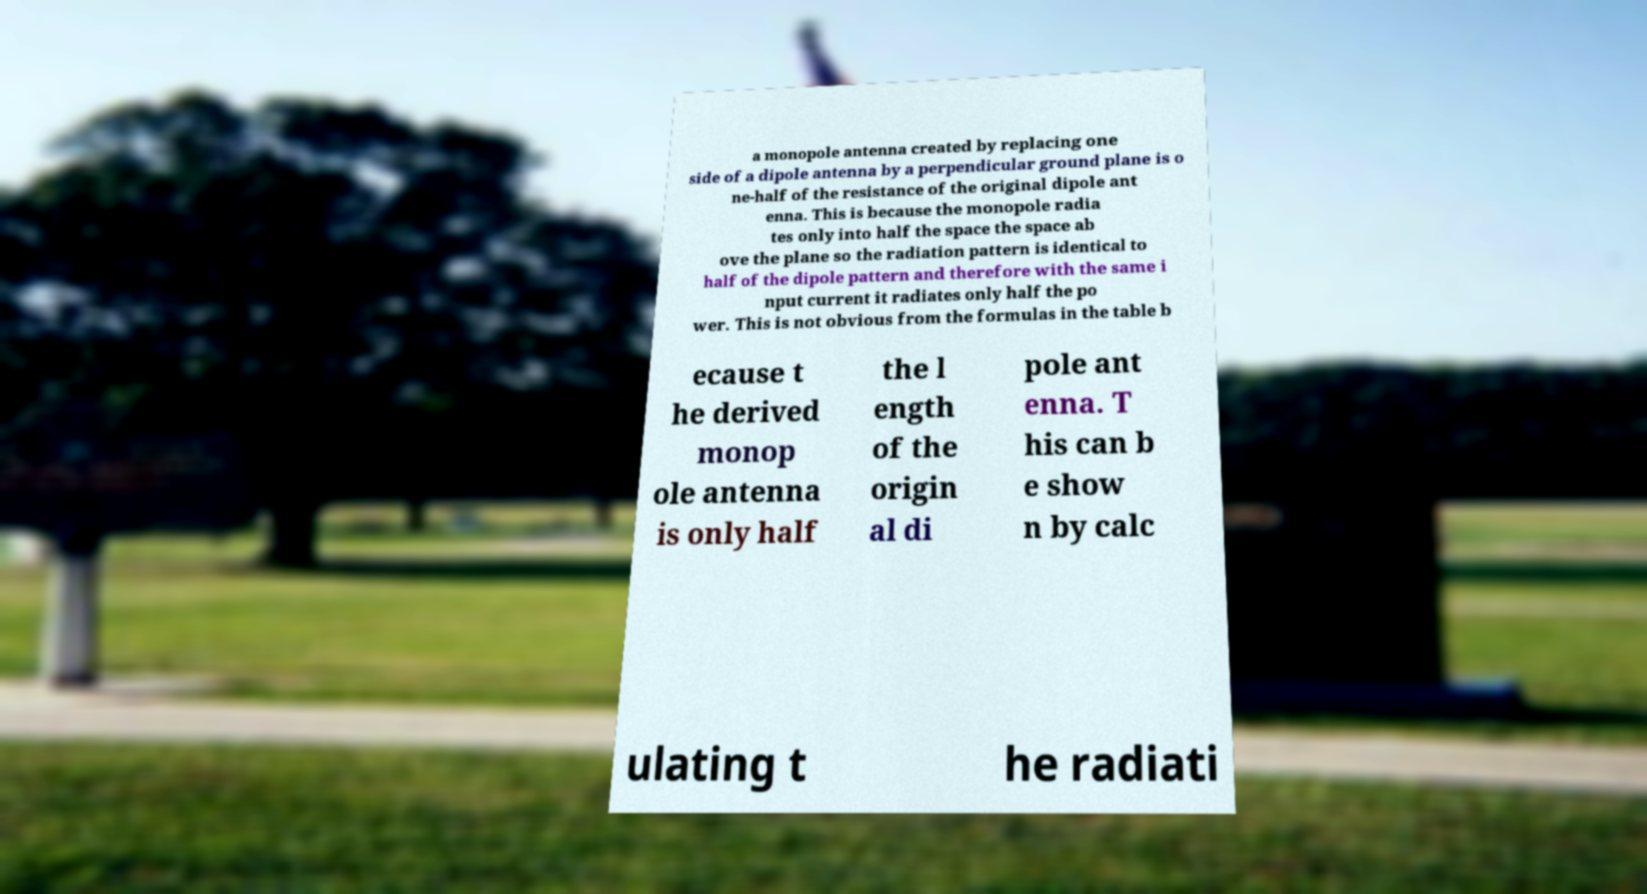Can you read and provide the text displayed in the image?This photo seems to have some interesting text. Can you extract and type it out for me? a monopole antenna created by replacing one side of a dipole antenna by a perpendicular ground plane is o ne-half of the resistance of the original dipole ant enna. This is because the monopole radia tes only into half the space the space ab ove the plane so the radiation pattern is identical to half of the dipole pattern and therefore with the same i nput current it radiates only half the po wer. This is not obvious from the formulas in the table b ecause t he derived monop ole antenna is only half the l ength of the origin al di pole ant enna. T his can b e show n by calc ulating t he radiati 